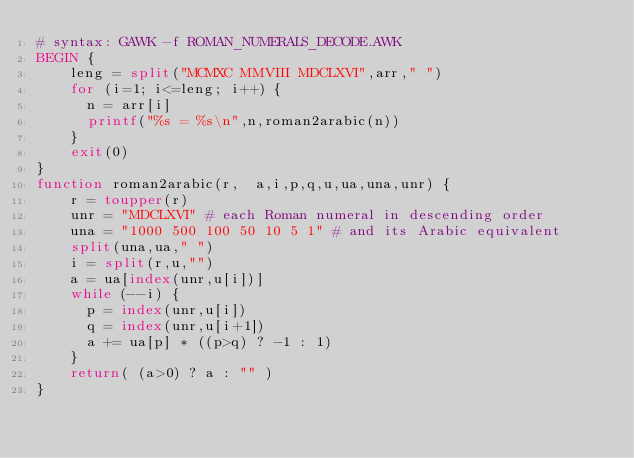<code> <loc_0><loc_0><loc_500><loc_500><_Awk_># syntax: GAWK -f ROMAN_NUMERALS_DECODE.AWK
BEGIN {
    leng = split("MCMXC MMVIII MDCLXVI",arr," ")
    for (i=1; i<=leng; i++) {
      n = arr[i]
      printf("%s = %s\n",n,roman2arabic(n))
    }
    exit(0)
}
function roman2arabic(r,  a,i,p,q,u,ua,una,unr) {
    r = toupper(r)
    unr = "MDCLXVI" # each Roman numeral in descending order
    una = "1000 500 100 50 10 5 1" # and its Arabic equivalent
    split(una,ua," ")
    i = split(r,u,"")
    a = ua[index(unr,u[i])]
    while (--i) {
      p = index(unr,u[i])
      q = index(unr,u[i+1])
      a += ua[p] * ((p>q) ? -1 : 1)
    }
    return( (a>0) ? a : "" )
}
</code> 